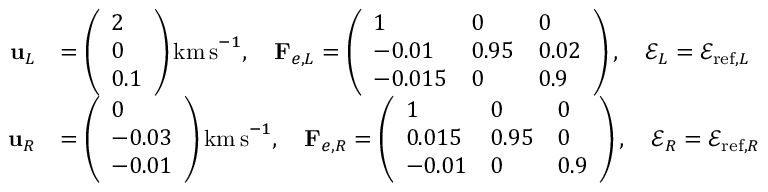Convert formula to latex. <formula><loc_0><loc_0><loc_500><loc_500>\begin{array} { r l } { u _ { L } } & { = \left ( \begin{array} { l } { 2 } \\ { 0 } \\ { 0 . 1 } \end{array} \right ) k m \, s ^ { - 1 } , \quad F _ { e , L } = \left ( \begin{array} { l l l } { 1 } & { 0 } & { 0 } \\ { - 0 . 0 1 } & { 0 . 9 5 } & { 0 . 0 2 } \\ { - 0 . 0 1 5 } & { 0 } & { 0 . 9 } \end{array} \right ) , \quad \ m a t h s c r { E } _ { L } = \ m a t h s c r { E } _ { r e f , L } } \\ { u _ { R } } & { = \left ( \begin{array} { l } { 0 } \\ { - 0 . 0 3 } \\ { - 0 . 0 1 } \end{array} \right ) k m \, s ^ { - 1 } , \quad F _ { e , R } = \left ( \begin{array} { l l l } { 1 } & { 0 } & { 0 } \\ { 0 . 0 1 5 } & { 0 . 9 5 } & { 0 } \\ { - 0 . 0 1 } & { 0 } & { 0 . 9 } \end{array} \right ) , \quad \ m a t h s c r { E } _ { R } = \ m a t h s c r { E } _ { r e f , R } } \end{array}</formula> 